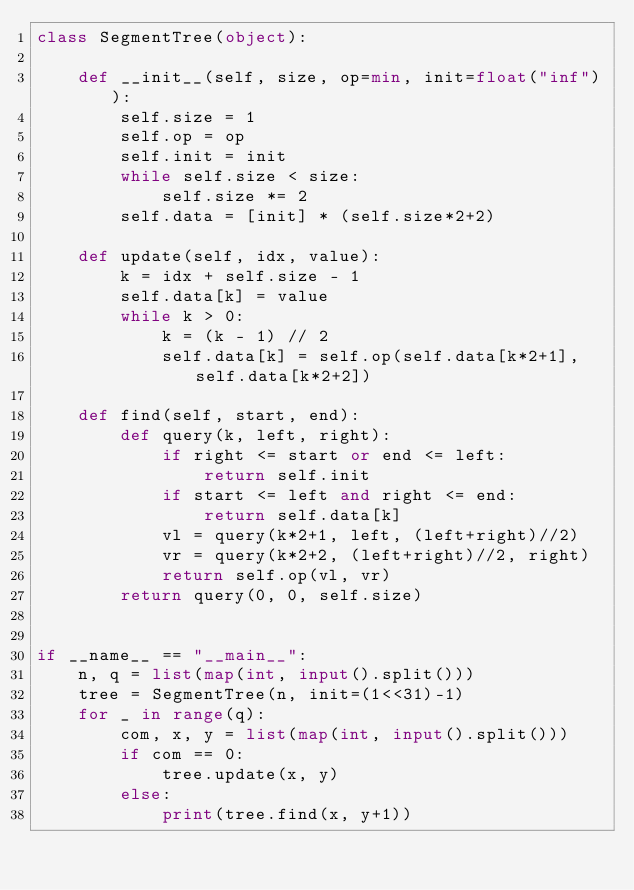<code> <loc_0><loc_0><loc_500><loc_500><_Python_>class SegmentTree(object):
 
    def __init__(self, size, op=min, init=float("inf")):
        self.size = 1
        self.op = op
        self.init = init
        while self.size < size:
            self.size *= 2
        self.data = [init] * (self.size*2+2)
 
    def update(self, idx, value):
        k = idx + self.size - 1
        self.data[k] = value
        while k > 0:
            k = (k - 1) // 2
            self.data[k] = self.op(self.data[k*2+1], self.data[k*2+2])
 
    def find(self, start, end):
        def query(k, left, right):
            if right <= start or end <= left:
                return self.init
            if start <= left and right <= end:
                return self.data[k]
            vl = query(k*2+1, left, (left+right)//2)
            vr = query(k*2+2, (left+right)//2, right)
            return self.op(vl, vr)
        return query(0, 0, self.size)
 

if __name__ == "__main__":
    n, q = list(map(int, input().split()))
    tree = SegmentTree(n, init=(1<<31)-1)
    for _ in range(q):
        com, x, y = list(map(int, input().split()))
        if com == 0:
            tree.update(x, y)
        else:
            print(tree.find(x, y+1))</code> 